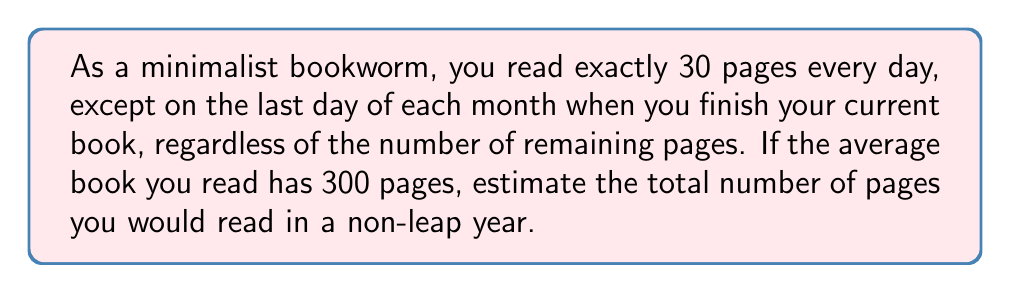Can you answer this question? Let's approach this step-by-step:

1) First, calculate the number of pages read on regular days:
   - There are 365 days in a non-leap year
   - 12 of these are last days of months
   - So, there are 353 regular reading days
   - Pages read on regular days = $353 \times 30 = 10,590$ pages

2) Now, let's consider the last day of each month:
   - There are 12 such days in a year
   - On average, you'll read half a book on these days (since you finish the book regardless of remaining pages)
   - Half of an average book = $300 \div 2 = 150$ pages
   - Pages read on last days of months = $12 \times 150 = 1,800$ pages

3) Total pages read in a year:
   $$ \text{Total} = \text{Regular days} + \text{Last days of months} $$
   $$ \text{Total} = 10,590 + 1,800 = 12,390 \text{ pages} $$
Answer: 12,390 pages 